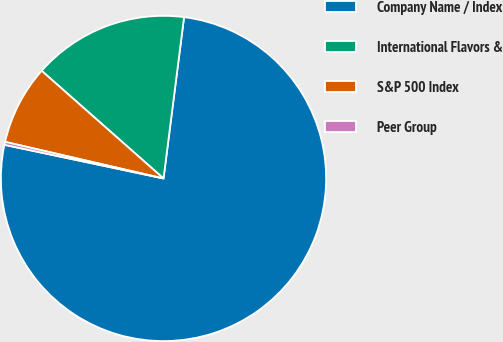Convert chart to OTSL. <chart><loc_0><loc_0><loc_500><loc_500><pie_chart><fcel>Company Name / Index<fcel>International Flavors &<fcel>S&P 500 Index<fcel>Peer Group<nl><fcel>76.3%<fcel>15.5%<fcel>7.9%<fcel>0.3%<nl></chart> 